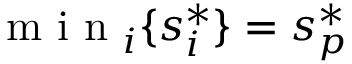Convert formula to latex. <formula><loc_0><loc_0><loc_500><loc_500>\min _ { i } \{ s _ { i } ^ { * } \} = s _ { p } ^ { * }</formula> 